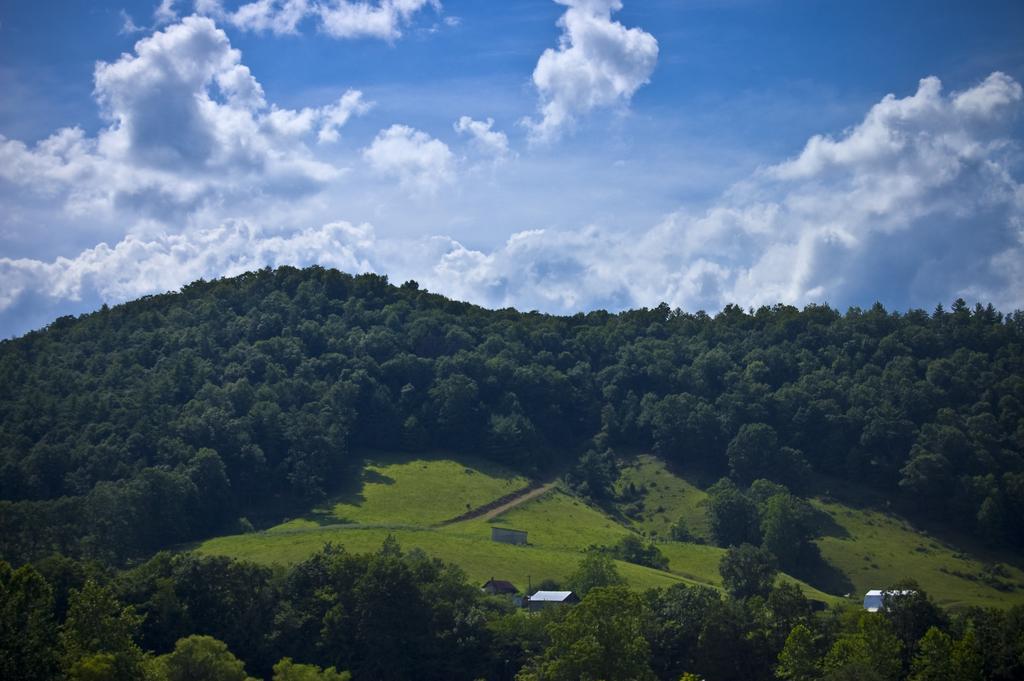How would you summarize this image in a sentence or two? In this image I can see mountains with full of trees and green grass. I can see some buildings. At the top of the image I can see the sky. 